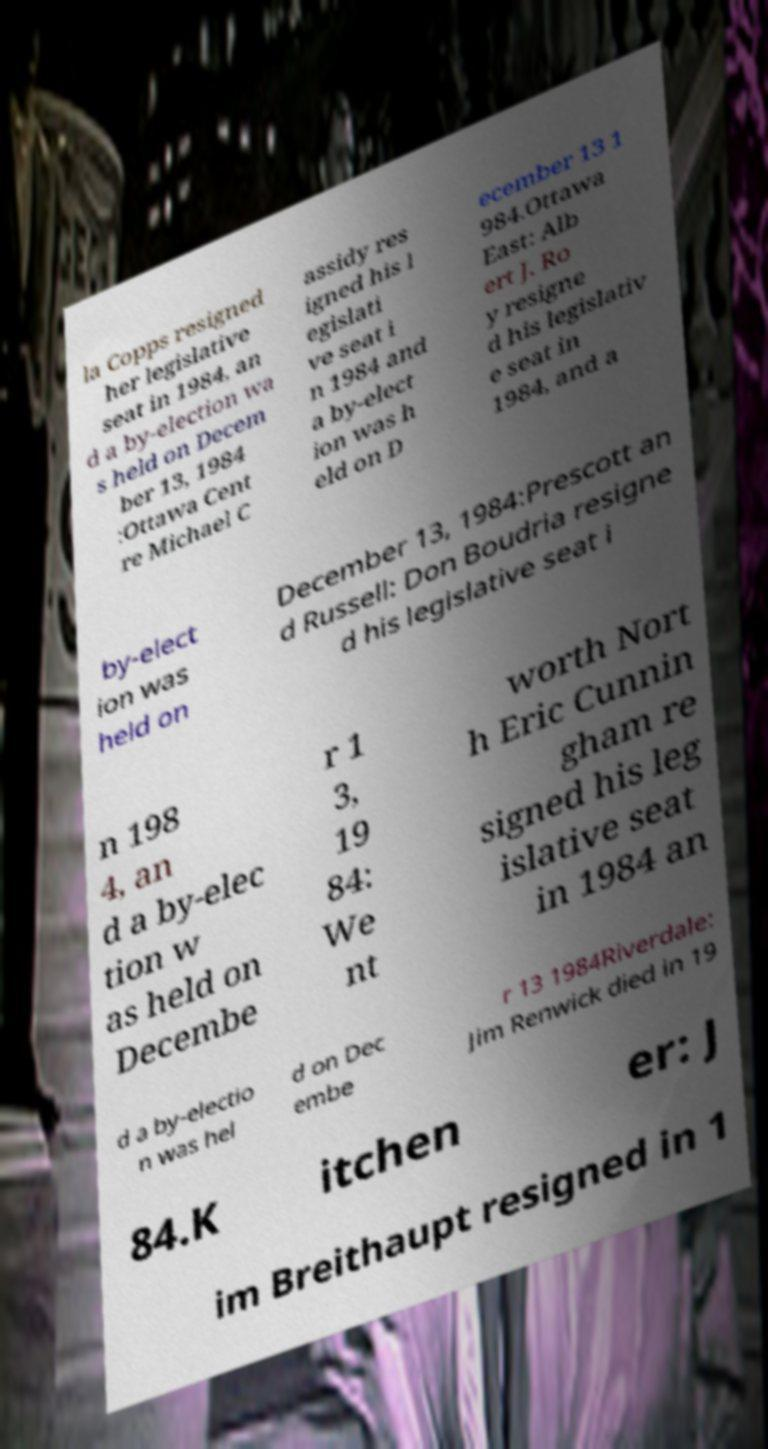What messages or text are displayed in this image? I need them in a readable, typed format. la Copps resigned her legislative seat in 1984, an d a by-election wa s held on Decem ber 13, 1984 :Ottawa Cent re Michael C assidy res igned his l egislati ve seat i n 1984 and a by-elect ion was h eld on D ecember 13 1 984.Ottawa East: Alb ert J. Ro y resigne d his legislativ e seat in 1984, and a by-elect ion was held on December 13, 1984:Prescott an d Russell: Don Boudria resigne d his legislative seat i n 198 4, an d a by-elec tion w as held on Decembe r 1 3, 19 84: We nt worth Nort h Eric Cunnin gham re signed his leg islative seat in 1984 an d a by-electio n was hel d on Dec embe r 13 1984Riverdale: Jim Renwick died in 19 84.K itchen er: J im Breithaupt resigned in 1 